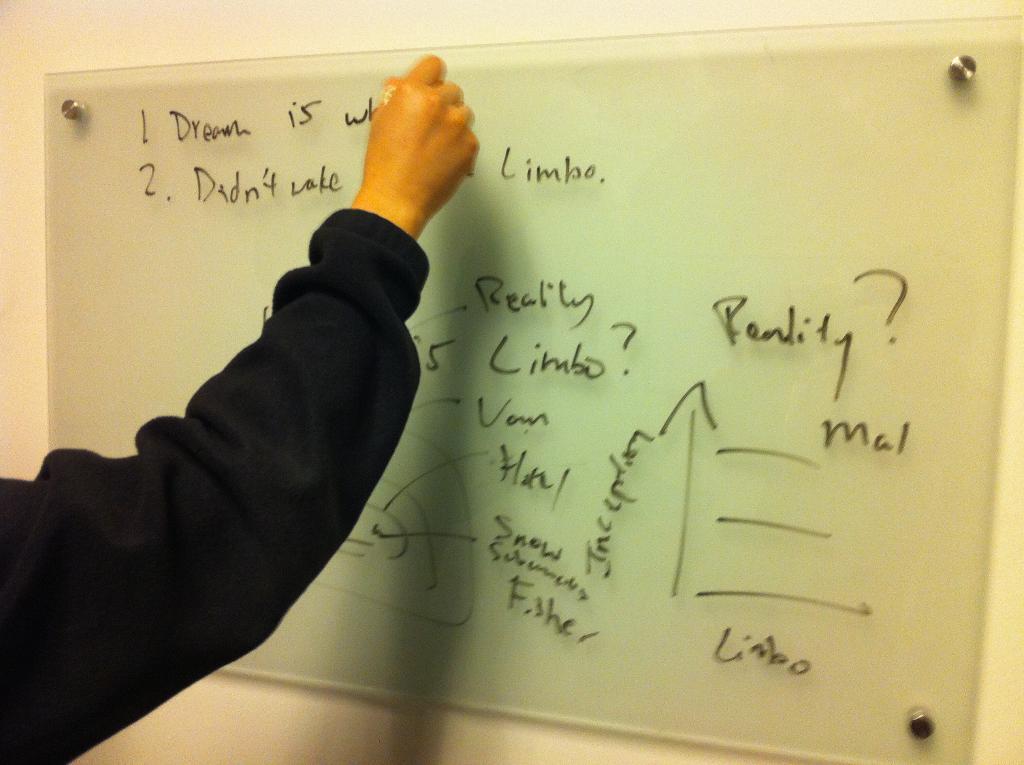How many question marks are there on the board?
Provide a succinct answer. 2. 